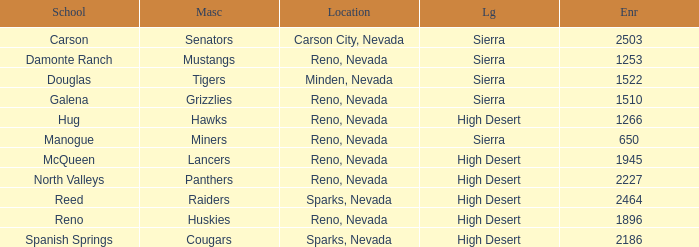What city and state is the Lancers mascot located? Reno, Nevada. Help me parse the entirety of this table. {'header': ['School', 'Masc', 'Location', 'Lg', 'Enr'], 'rows': [['Carson', 'Senators', 'Carson City, Nevada', 'Sierra', '2503'], ['Damonte Ranch', 'Mustangs', 'Reno, Nevada', 'Sierra', '1253'], ['Douglas', 'Tigers', 'Minden, Nevada', 'Sierra', '1522'], ['Galena', 'Grizzlies', 'Reno, Nevada', 'Sierra', '1510'], ['Hug', 'Hawks', 'Reno, Nevada', 'High Desert', '1266'], ['Manogue', 'Miners', 'Reno, Nevada', 'Sierra', '650'], ['McQueen', 'Lancers', 'Reno, Nevada', 'High Desert', '1945'], ['North Valleys', 'Panthers', 'Reno, Nevada', 'High Desert', '2227'], ['Reed', 'Raiders', 'Sparks, Nevada', 'High Desert', '2464'], ['Reno', 'Huskies', 'Reno, Nevada', 'High Desert', '1896'], ['Spanish Springs', 'Cougars', 'Sparks, Nevada', 'High Desert', '2186']]} 